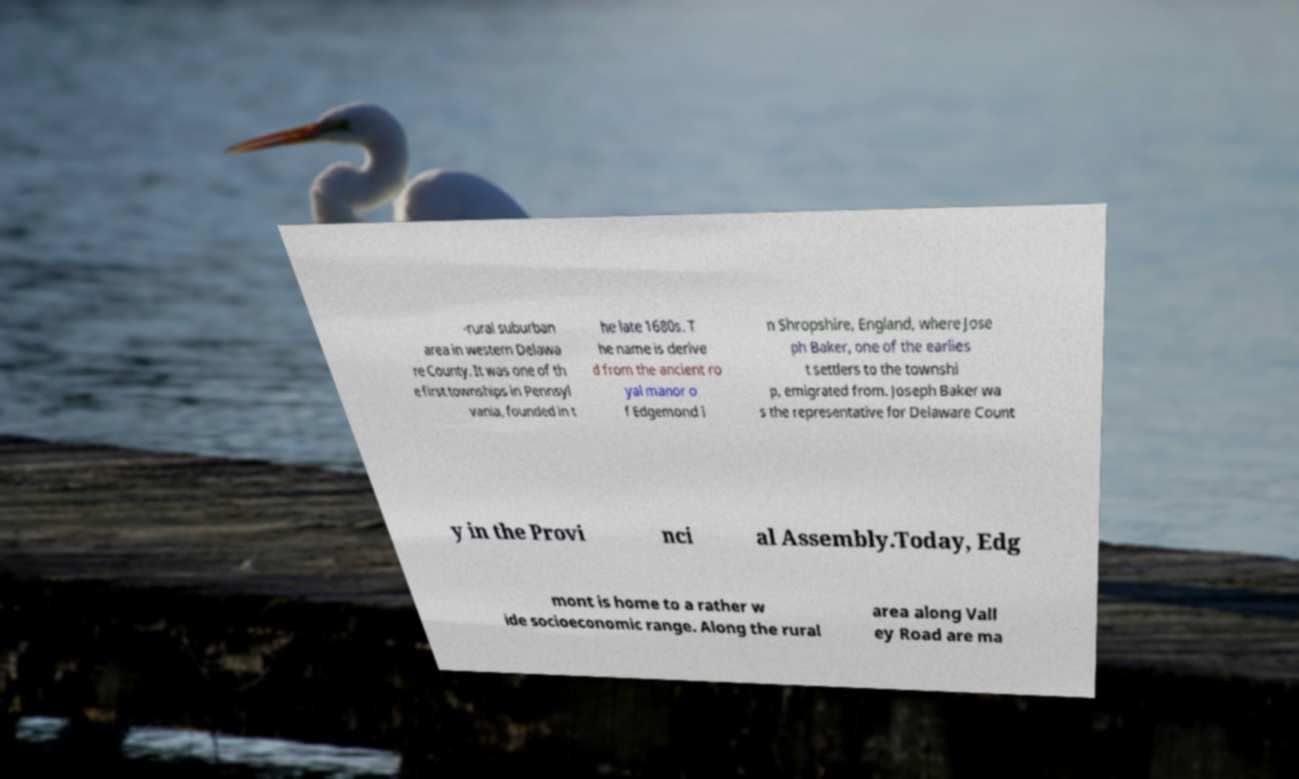Please read and relay the text visible in this image. What does it say? -rural suburban area in western Delawa re County. It was one of th e first townships in Pennsyl vania, founded in t he late 1680s. T he name is derive d from the ancient ro yal manor o f Edgemond i n Shropshire, England, where Jose ph Baker, one of the earlies t settlers to the townshi p, emigrated from. Joseph Baker wa s the representative for Delaware Count y in the Provi nci al Assembly.Today, Edg mont is home to a rather w ide socioeconomic range. Along the rural area along Vall ey Road are ma 